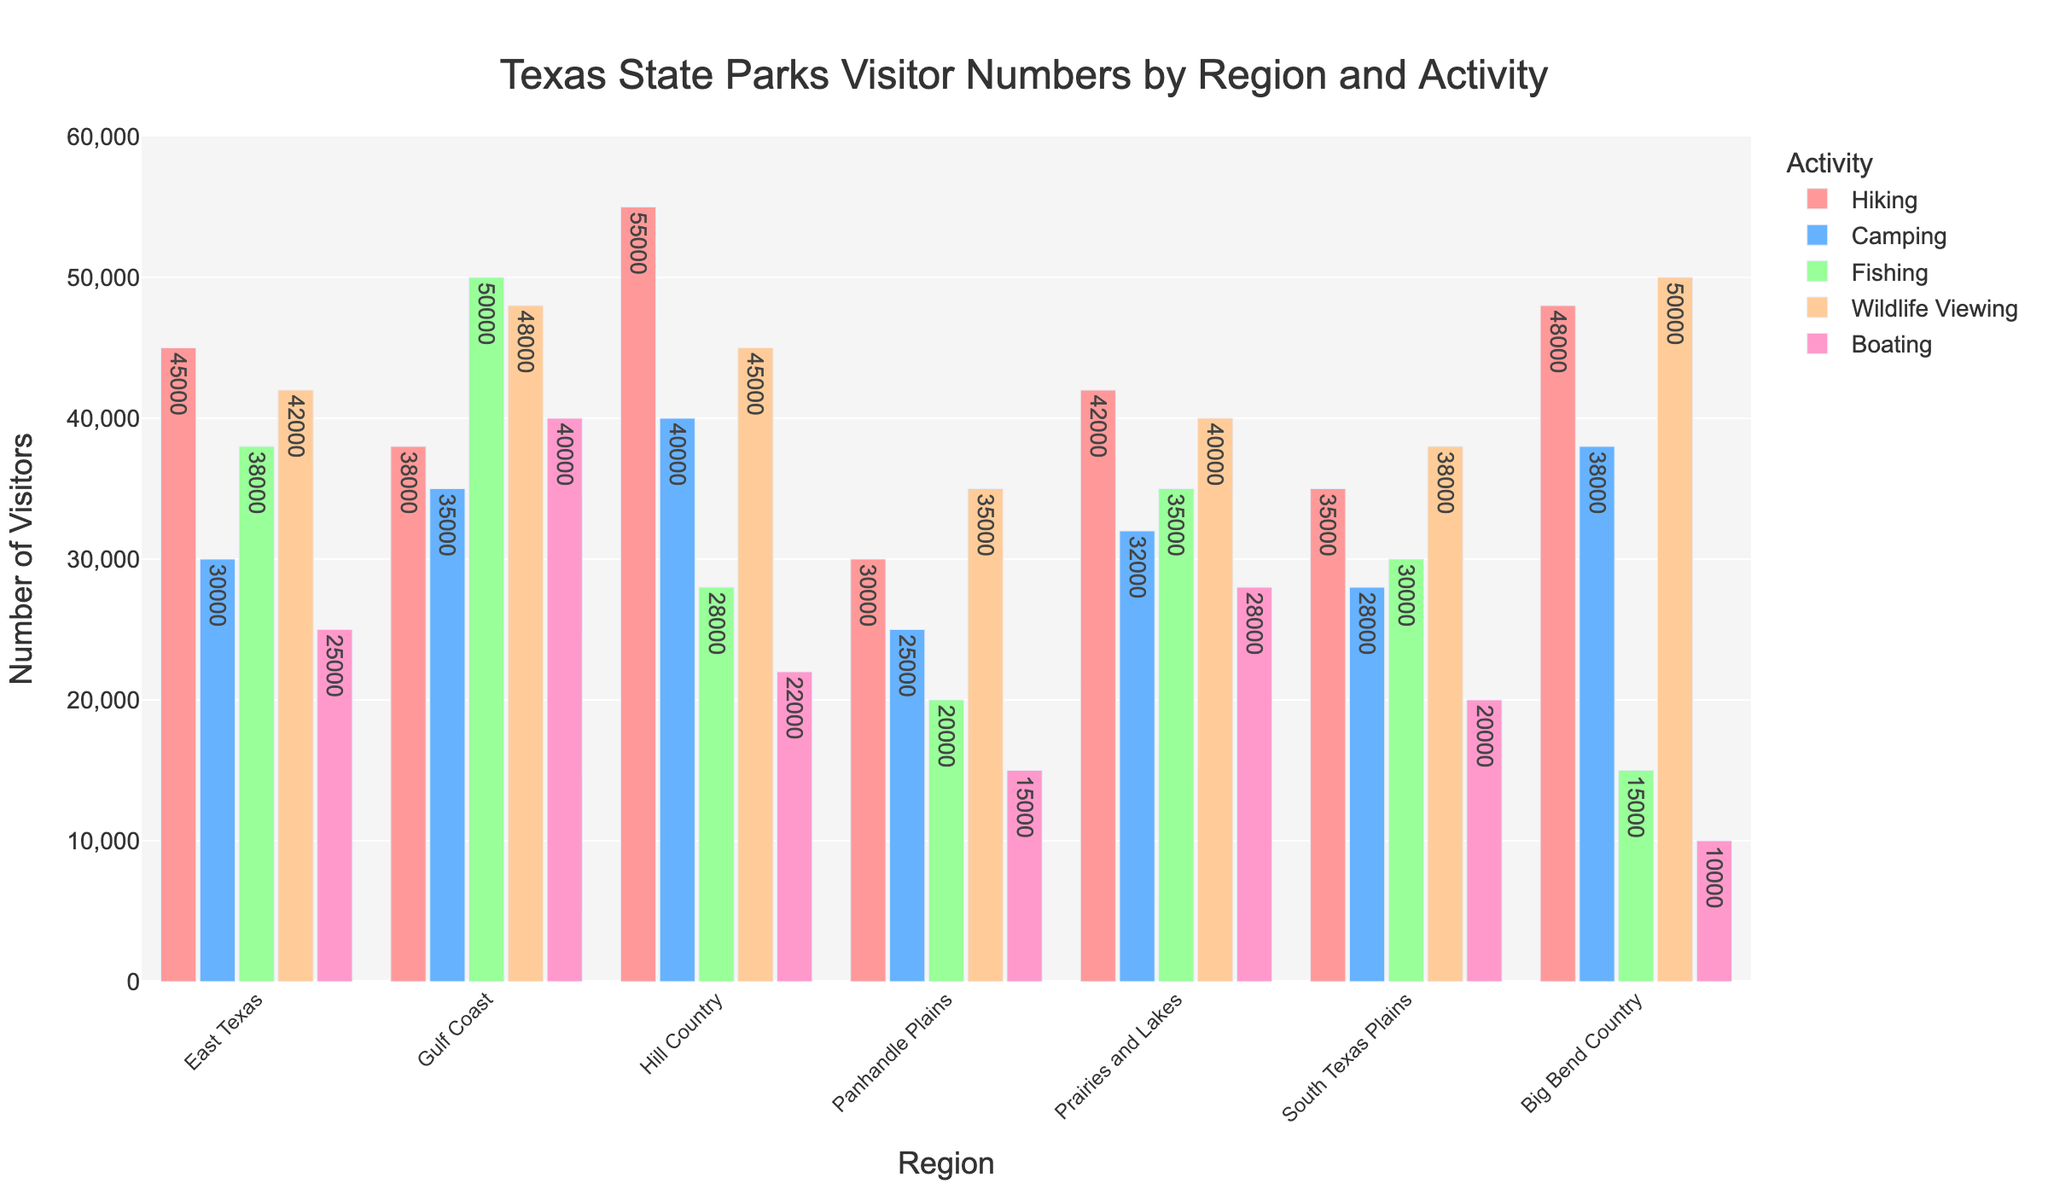Which region has the highest number of visitors for hiking? Look at the bars representing hiking activity across the regions. Identify the bar that is the tallest.
Answer: Hill Country Which recreational activity has the lowest number of visitors in Big Bend Country? Inspect the heights of the bars for different activities in Big Bend Country. Find the shortest bar.
Answer: Boating Compare the total number of visitors for fishing in East Texas and Gulf Coast. Which one has more visitors and by how much? Find the bars representing fishing activity in East Texas and Gulf Coast. Subtract the value of East Texas from Gulf Coast to find the difference.
Answer: Gulf Coast, by 12,000 Which region has the most balanced visitor numbers (least variation) across all activities? Examine the heights of bars in each region. Identify which region has bars of similar heights across activities.
Answer: Prairies and Lakes What is the difference in the number of camping visitors between Hill Country and South Texas Plains? Check the bars for camping in Hill Country and South Texas Plains. Subtract the value of South Texas Plains from Hill Country.
Answer: 12,000 What's the total number of visitors for hiking in the Panhandle Plains, Prairies and Lakes, and South Texas Plains combined? Sum the heights of the bars for hiking in Panhandle Plains, Prairies and Lakes, and South Texas Plains.
Answer: 107,000 Which region has the highest number of visitors for wildlife viewing? Look at the bars representing wildlife viewing activity across the regions. Identify the tallest bar.
Answer: Big Bend Country Compare the number of visitors for boating in Gulf Coast and Hill Country. Which region has more, and by how much? Look at the bars for boating in both Gulf Coast and Hill Country. Subtract the value of Hill Country from Gulf Coast to find the difference.
Answer: Gulf Coast, by 18,000 What is the average number of visitors for all activities in the East Texas region? Sum the visitor numbers for all activities in East Texas and divide by the number of activities (5).
Answer: 36,600 